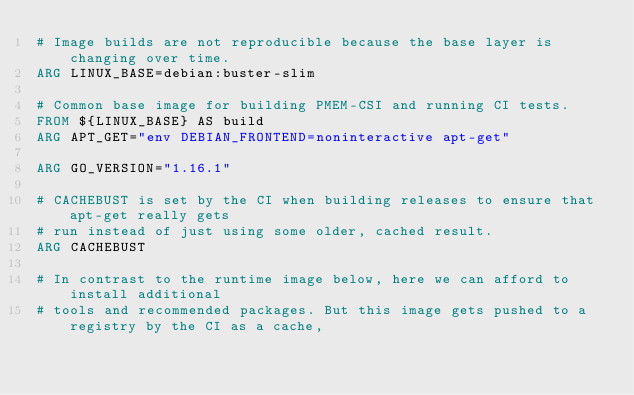Convert code to text. <code><loc_0><loc_0><loc_500><loc_500><_Dockerfile_># Image builds are not reproducible because the base layer is changing over time.
ARG LINUX_BASE=debian:buster-slim

# Common base image for building PMEM-CSI and running CI tests.
FROM ${LINUX_BASE} AS build
ARG APT_GET="env DEBIAN_FRONTEND=noninteractive apt-get"

ARG GO_VERSION="1.16.1"

# CACHEBUST is set by the CI when building releases to ensure that apt-get really gets
# run instead of just using some older, cached result.
ARG CACHEBUST

# In contrast to the runtime image below, here we can afford to install additional
# tools and recommended packages. But this image gets pushed to a registry by the CI as a cache,</code> 